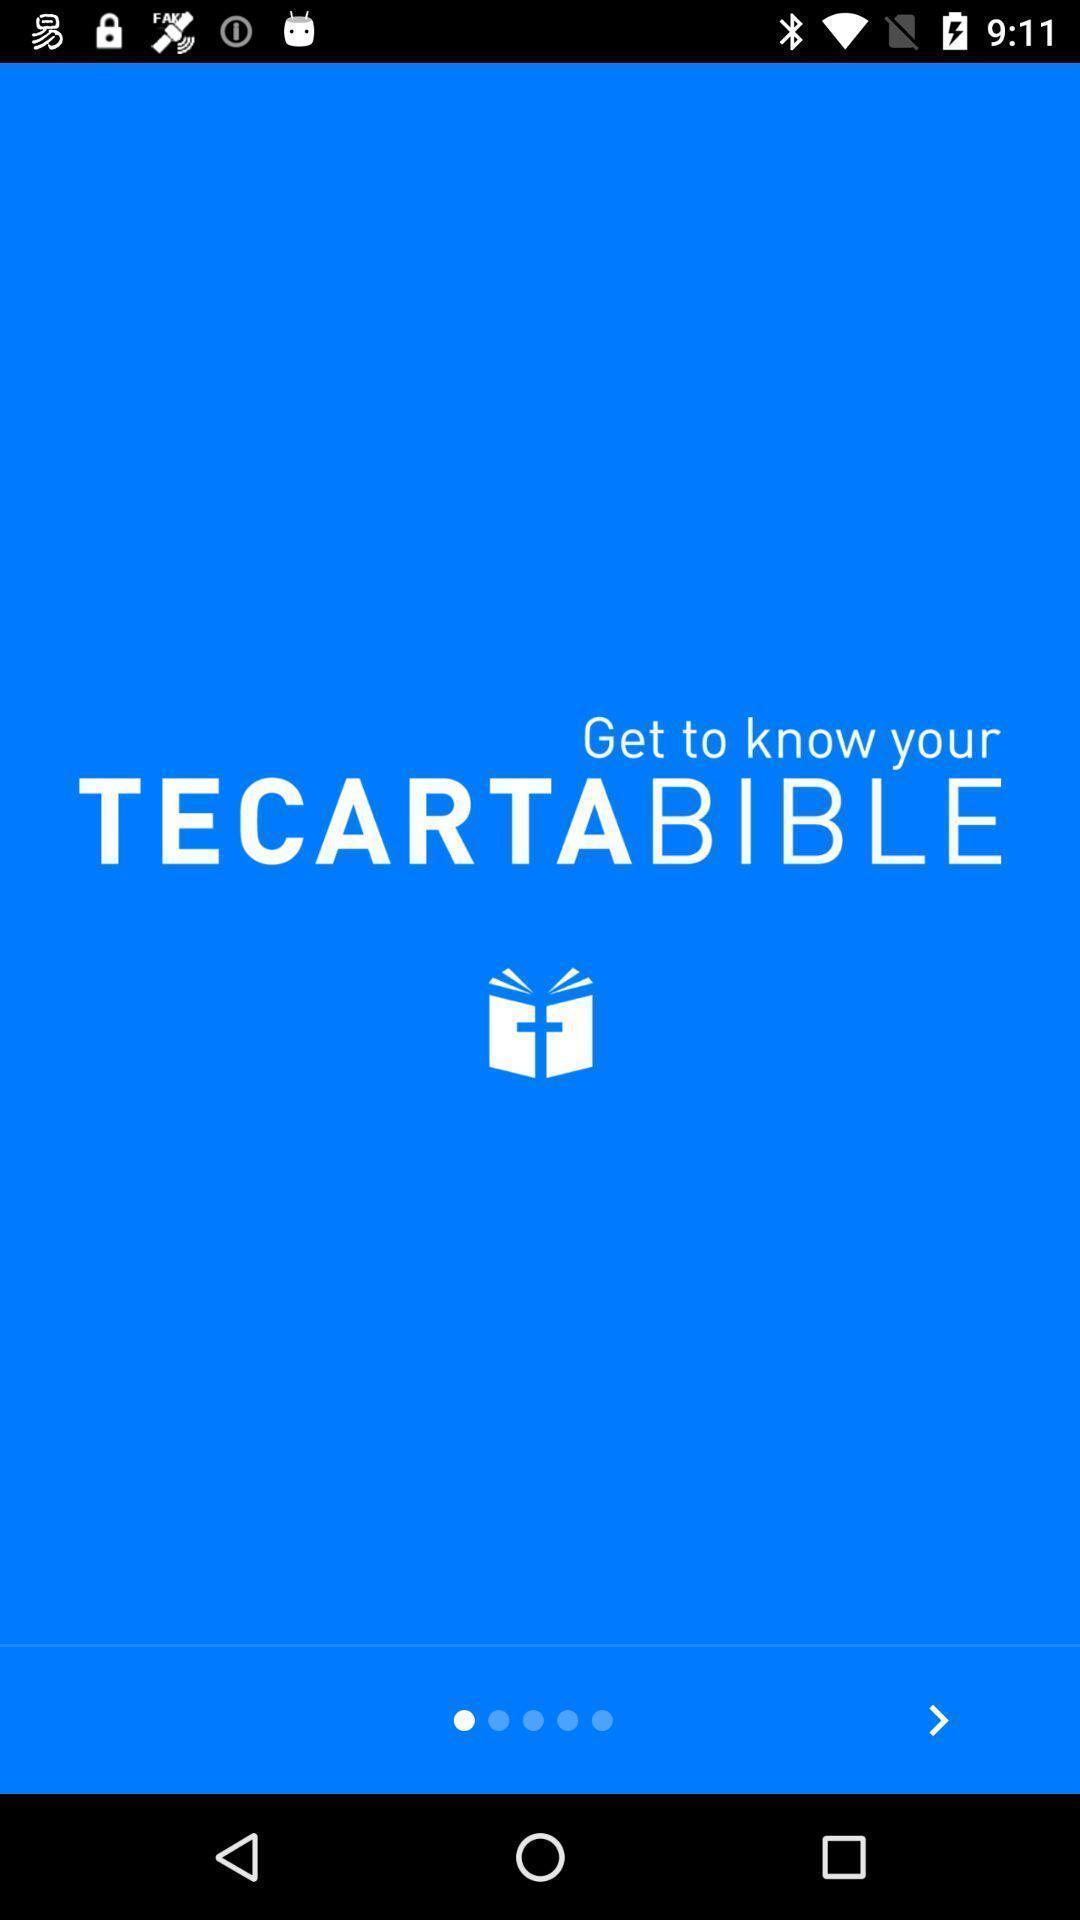Give me a summary of this screen capture. Welcome page. 